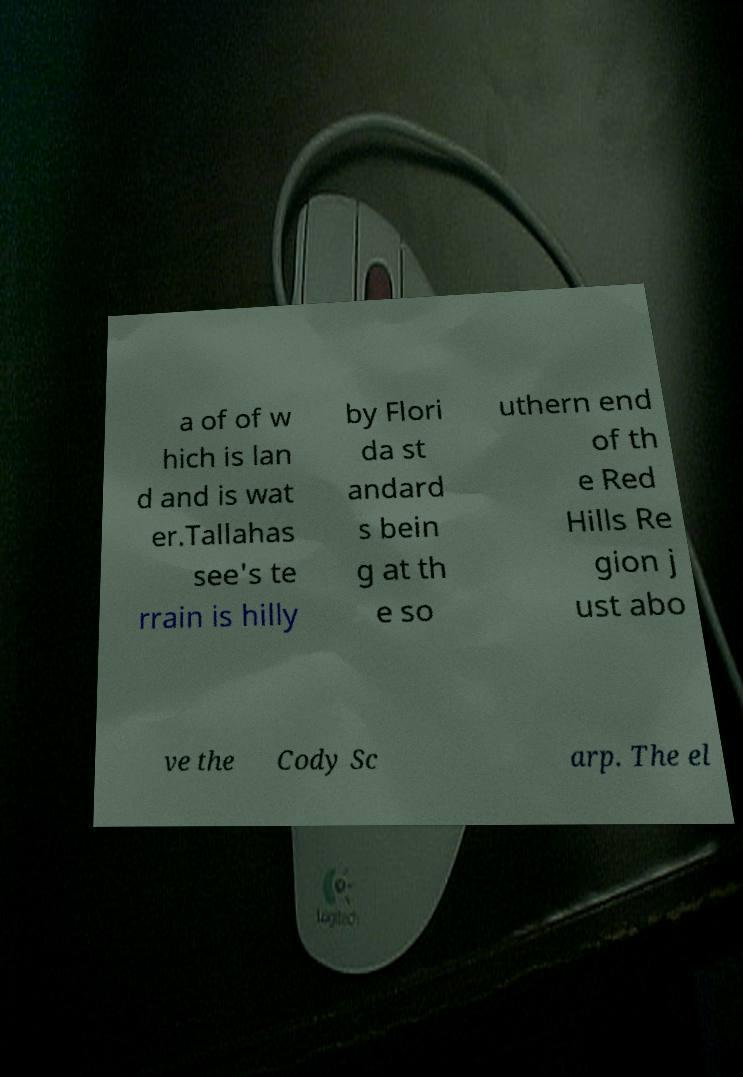Please identify and transcribe the text found in this image. a of of w hich is lan d and is wat er.Tallahas see's te rrain is hilly by Flori da st andard s bein g at th e so uthern end of th e Red Hills Re gion j ust abo ve the Cody Sc arp. The el 